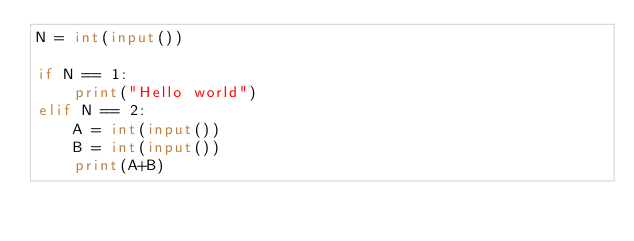<code> <loc_0><loc_0><loc_500><loc_500><_Python_>N = int(input())

if N == 1:
    print("Hello world")
elif N == 2:
    A = int(input())
    B = int(input())
    print(A+B)
</code> 